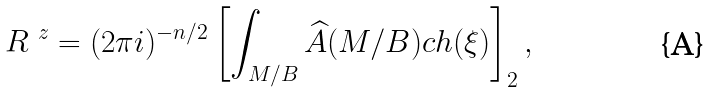Convert formula to latex. <formula><loc_0><loc_0><loc_500><loc_500>R ^ { \ z } = ( 2 \pi i ) ^ { - n / 2 } \left [ \int _ { M / B } \widehat { A } ( M / B ) c h ( \xi ) \right ] _ { 2 } ,</formula> 